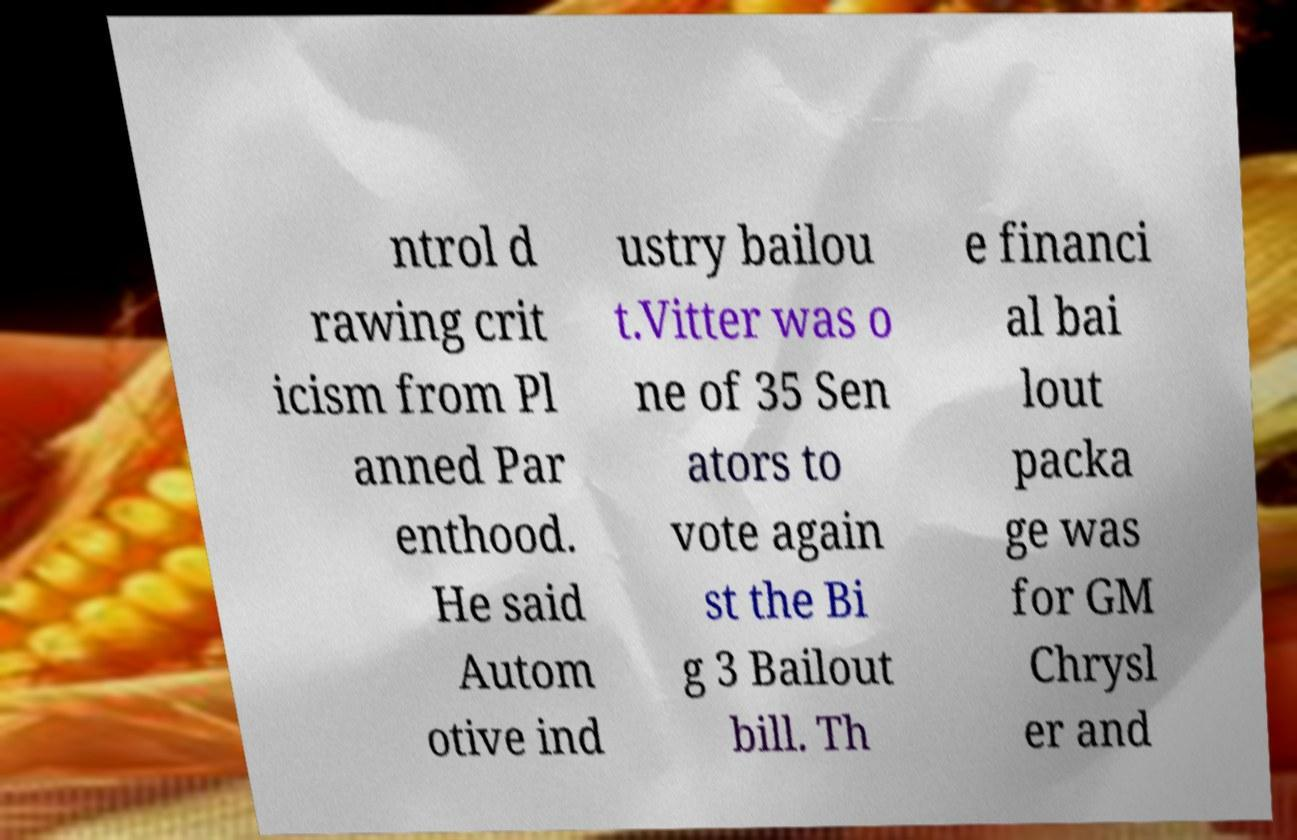I need the written content from this picture converted into text. Can you do that? ntrol d rawing crit icism from Pl anned Par enthood. He said Autom otive ind ustry bailou t.Vitter was o ne of 35 Sen ators to vote again st the Bi g 3 Bailout bill. Th e financi al bai lout packa ge was for GM Chrysl er and 